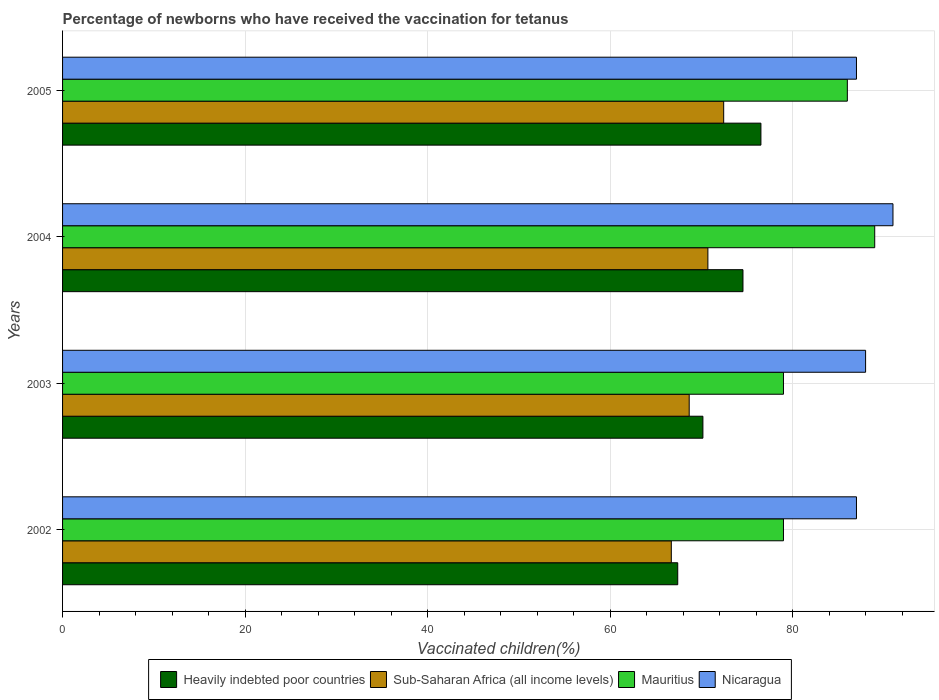How many groups of bars are there?
Ensure brevity in your answer.  4. Are the number of bars on each tick of the Y-axis equal?
Give a very brief answer. Yes. How many bars are there on the 2nd tick from the top?
Give a very brief answer. 4. How many bars are there on the 2nd tick from the bottom?
Provide a short and direct response. 4. What is the label of the 1st group of bars from the top?
Provide a short and direct response. 2005. In how many cases, is the number of bars for a given year not equal to the number of legend labels?
Make the answer very short. 0. What is the percentage of vaccinated children in Sub-Saharan Africa (all income levels) in 2002?
Ensure brevity in your answer.  66.71. Across all years, what is the maximum percentage of vaccinated children in Nicaragua?
Offer a terse response. 91. Across all years, what is the minimum percentage of vaccinated children in Sub-Saharan Africa (all income levels)?
Keep it short and to the point. 66.71. What is the total percentage of vaccinated children in Heavily indebted poor countries in the graph?
Give a very brief answer. 288.68. What is the difference between the percentage of vaccinated children in Heavily indebted poor countries in 2003 and that in 2005?
Provide a short and direct response. -6.36. What is the difference between the percentage of vaccinated children in Heavily indebted poor countries in 2004 and the percentage of vaccinated children in Sub-Saharan Africa (all income levels) in 2002?
Provide a short and direct response. 7.85. What is the average percentage of vaccinated children in Mauritius per year?
Offer a terse response. 83.25. In the year 2004, what is the difference between the percentage of vaccinated children in Heavily indebted poor countries and percentage of vaccinated children in Sub-Saharan Africa (all income levels)?
Your answer should be very brief. 3.85. What is the ratio of the percentage of vaccinated children in Nicaragua in 2003 to that in 2005?
Make the answer very short. 1.01. Is the percentage of vaccinated children in Heavily indebted poor countries in 2003 less than that in 2005?
Offer a terse response. Yes. What is the difference between the highest and the second highest percentage of vaccinated children in Heavily indebted poor countries?
Provide a short and direct response. 1.97. What is the difference between the highest and the lowest percentage of vaccinated children in Heavily indebted poor countries?
Ensure brevity in your answer.  9.12. Is the sum of the percentage of vaccinated children in Sub-Saharan Africa (all income levels) in 2003 and 2005 greater than the maximum percentage of vaccinated children in Nicaragua across all years?
Your answer should be compact. Yes. What does the 1st bar from the top in 2002 represents?
Make the answer very short. Nicaragua. What does the 2nd bar from the bottom in 2003 represents?
Your answer should be compact. Sub-Saharan Africa (all income levels). Are all the bars in the graph horizontal?
Give a very brief answer. Yes. What is the difference between two consecutive major ticks on the X-axis?
Offer a terse response. 20. Does the graph contain any zero values?
Offer a very short reply. No. How many legend labels are there?
Your answer should be compact. 4. How are the legend labels stacked?
Your answer should be very brief. Horizontal. What is the title of the graph?
Provide a short and direct response. Percentage of newborns who have received the vaccination for tetanus. What is the label or title of the X-axis?
Make the answer very short. Vaccinated children(%). What is the label or title of the Y-axis?
Your response must be concise. Years. What is the Vaccinated children(%) of Heavily indebted poor countries in 2002?
Ensure brevity in your answer.  67.41. What is the Vaccinated children(%) of Sub-Saharan Africa (all income levels) in 2002?
Provide a succinct answer. 66.71. What is the Vaccinated children(%) in Mauritius in 2002?
Make the answer very short. 79. What is the Vaccinated children(%) of Heavily indebted poor countries in 2003?
Your answer should be very brief. 70.17. What is the Vaccinated children(%) of Sub-Saharan Africa (all income levels) in 2003?
Give a very brief answer. 68.67. What is the Vaccinated children(%) in Mauritius in 2003?
Your answer should be compact. 79. What is the Vaccinated children(%) of Nicaragua in 2003?
Give a very brief answer. 88. What is the Vaccinated children(%) in Heavily indebted poor countries in 2004?
Your response must be concise. 74.56. What is the Vaccinated children(%) in Sub-Saharan Africa (all income levels) in 2004?
Your answer should be compact. 70.72. What is the Vaccinated children(%) in Mauritius in 2004?
Your response must be concise. 89. What is the Vaccinated children(%) in Nicaragua in 2004?
Your answer should be compact. 91. What is the Vaccinated children(%) of Heavily indebted poor countries in 2005?
Offer a very short reply. 76.53. What is the Vaccinated children(%) of Sub-Saharan Africa (all income levels) in 2005?
Offer a terse response. 72.45. What is the Vaccinated children(%) of Mauritius in 2005?
Give a very brief answer. 86. What is the Vaccinated children(%) of Nicaragua in 2005?
Provide a succinct answer. 87. Across all years, what is the maximum Vaccinated children(%) in Heavily indebted poor countries?
Your answer should be very brief. 76.53. Across all years, what is the maximum Vaccinated children(%) in Sub-Saharan Africa (all income levels)?
Provide a short and direct response. 72.45. Across all years, what is the maximum Vaccinated children(%) in Mauritius?
Your response must be concise. 89. Across all years, what is the maximum Vaccinated children(%) in Nicaragua?
Your answer should be very brief. 91. Across all years, what is the minimum Vaccinated children(%) in Heavily indebted poor countries?
Provide a short and direct response. 67.41. Across all years, what is the minimum Vaccinated children(%) of Sub-Saharan Africa (all income levels)?
Offer a terse response. 66.71. Across all years, what is the minimum Vaccinated children(%) of Mauritius?
Ensure brevity in your answer.  79. Across all years, what is the minimum Vaccinated children(%) in Nicaragua?
Offer a very short reply. 87. What is the total Vaccinated children(%) in Heavily indebted poor countries in the graph?
Provide a short and direct response. 288.68. What is the total Vaccinated children(%) of Sub-Saharan Africa (all income levels) in the graph?
Your response must be concise. 278.55. What is the total Vaccinated children(%) in Mauritius in the graph?
Provide a succinct answer. 333. What is the total Vaccinated children(%) of Nicaragua in the graph?
Give a very brief answer. 353. What is the difference between the Vaccinated children(%) of Heavily indebted poor countries in 2002 and that in 2003?
Provide a succinct answer. -2.76. What is the difference between the Vaccinated children(%) of Sub-Saharan Africa (all income levels) in 2002 and that in 2003?
Ensure brevity in your answer.  -1.96. What is the difference between the Vaccinated children(%) in Mauritius in 2002 and that in 2003?
Your answer should be very brief. 0. What is the difference between the Vaccinated children(%) in Heavily indebted poor countries in 2002 and that in 2004?
Provide a succinct answer. -7.15. What is the difference between the Vaccinated children(%) in Sub-Saharan Africa (all income levels) in 2002 and that in 2004?
Your answer should be very brief. -4.01. What is the difference between the Vaccinated children(%) in Nicaragua in 2002 and that in 2004?
Offer a terse response. -4. What is the difference between the Vaccinated children(%) in Heavily indebted poor countries in 2002 and that in 2005?
Make the answer very short. -9.12. What is the difference between the Vaccinated children(%) of Sub-Saharan Africa (all income levels) in 2002 and that in 2005?
Your answer should be compact. -5.74. What is the difference between the Vaccinated children(%) in Heavily indebted poor countries in 2003 and that in 2004?
Give a very brief answer. -4.39. What is the difference between the Vaccinated children(%) in Sub-Saharan Africa (all income levels) in 2003 and that in 2004?
Give a very brief answer. -2.05. What is the difference between the Vaccinated children(%) in Heavily indebted poor countries in 2003 and that in 2005?
Make the answer very short. -6.36. What is the difference between the Vaccinated children(%) in Sub-Saharan Africa (all income levels) in 2003 and that in 2005?
Give a very brief answer. -3.78. What is the difference between the Vaccinated children(%) in Mauritius in 2003 and that in 2005?
Make the answer very short. -7. What is the difference between the Vaccinated children(%) in Heavily indebted poor countries in 2004 and that in 2005?
Make the answer very short. -1.97. What is the difference between the Vaccinated children(%) of Sub-Saharan Africa (all income levels) in 2004 and that in 2005?
Give a very brief answer. -1.73. What is the difference between the Vaccinated children(%) in Heavily indebted poor countries in 2002 and the Vaccinated children(%) in Sub-Saharan Africa (all income levels) in 2003?
Give a very brief answer. -1.26. What is the difference between the Vaccinated children(%) in Heavily indebted poor countries in 2002 and the Vaccinated children(%) in Mauritius in 2003?
Ensure brevity in your answer.  -11.59. What is the difference between the Vaccinated children(%) of Heavily indebted poor countries in 2002 and the Vaccinated children(%) of Nicaragua in 2003?
Offer a terse response. -20.59. What is the difference between the Vaccinated children(%) of Sub-Saharan Africa (all income levels) in 2002 and the Vaccinated children(%) of Mauritius in 2003?
Your answer should be compact. -12.29. What is the difference between the Vaccinated children(%) in Sub-Saharan Africa (all income levels) in 2002 and the Vaccinated children(%) in Nicaragua in 2003?
Provide a succinct answer. -21.29. What is the difference between the Vaccinated children(%) in Heavily indebted poor countries in 2002 and the Vaccinated children(%) in Sub-Saharan Africa (all income levels) in 2004?
Make the answer very short. -3.3. What is the difference between the Vaccinated children(%) of Heavily indebted poor countries in 2002 and the Vaccinated children(%) of Mauritius in 2004?
Keep it short and to the point. -21.59. What is the difference between the Vaccinated children(%) in Heavily indebted poor countries in 2002 and the Vaccinated children(%) in Nicaragua in 2004?
Make the answer very short. -23.59. What is the difference between the Vaccinated children(%) of Sub-Saharan Africa (all income levels) in 2002 and the Vaccinated children(%) of Mauritius in 2004?
Give a very brief answer. -22.29. What is the difference between the Vaccinated children(%) in Sub-Saharan Africa (all income levels) in 2002 and the Vaccinated children(%) in Nicaragua in 2004?
Make the answer very short. -24.29. What is the difference between the Vaccinated children(%) in Heavily indebted poor countries in 2002 and the Vaccinated children(%) in Sub-Saharan Africa (all income levels) in 2005?
Keep it short and to the point. -5.04. What is the difference between the Vaccinated children(%) of Heavily indebted poor countries in 2002 and the Vaccinated children(%) of Mauritius in 2005?
Provide a succinct answer. -18.59. What is the difference between the Vaccinated children(%) in Heavily indebted poor countries in 2002 and the Vaccinated children(%) in Nicaragua in 2005?
Keep it short and to the point. -19.59. What is the difference between the Vaccinated children(%) of Sub-Saharan Africa (all income levels) in 2002 and the Vaccinated children(%) of Mauritius in 2005?
Offer a very short reply. -19.29. What is the difference between the Vaccinated children(%) in Sub-Saharan Africa (all income levels) in 2002 and the Vaccinated children(%) in Nicaragua in 2005?
Provide a succinct answer. -20.29. What is the difference between the Vaccinated children(%) in Heavily indebted poor countries in 2003 and the Vaccinated children(%) in Sub-Saharan Africa (all income levels) in 2004?
Provide a succinct answer. -0.54. What is the difference between the Vaccinated children(%) in Heavily indebted poor countries in 2003 and the Vaccinated children(%) in Mauritius in 2004?
Your answer should be very brief. -18.83. What is the difference between the Vaccinated children(%) of Heavily indebted poor countries in 2003 and the Vaccinated children(%) of Nicaragua in 2004?
Give a very brief answer. -20.83. What is the difference between the Vaccinated children(%) of Sub-Saharan Africa (all income levels) in 2003 and the Vaccinated children(%) of Mauritius in 2004?
Your answer should be very brief. -20.33. What is the difference between the Vaccinated children(%) of Sub-Saharan Africa (all income levels) in 2003 and the Vaccinated children(%) of Nicaragua in 2004?
Provide a succinct answer. -22.33. What is the difference between the Vaccinated children(%) in Mauritius in 2003 and the Vaccinated children(%) in Nicaragua in 2004?
Offer a very short reply. -12. What is the difference between the Vaccinated children(%) of Heavily indebted poor countries in 2003 and the Vaccinated children(%) of Sub-Saharan Africa (all income levels) in 2005?
Ensure brevity in your answer.  -2.28. What is the difference between the Vaccinated children(%) in Heavily indebted poor countries in 2003 and the Vaccinated children(%) in Mauritius in 2005?
Provide a succinct answer. -15.83. What is the difference between the Vaccinated children(%) of Heavily indebted poor countries in 2003 and the Vaccinated children(%) of Nicaragua in 2005?
Ensure brevity in your answer.  -16.83. What is the difference between the Vaccinated children(%) of Sub-Saharan Africa (all income levels) in 2003 and the Vaccinated children(%) of Mauritius in 2005?
Ensure brevity in your answer.  -17.33. What is the difference between the Vaccinated children(%) of Sub-Saharan Africa (all income levels) in 2003 and the Vaccinated children(%) of Nicaragua in 2005?
Your answer should be very brief. -18.33. What is the difference between the Vaccinated children(%) in Heavily indebted poor countries in 2004 and the Vaccinated children(%) in Sub-Saharan Africa (all income levels) in 2005?
Offer a very short reply. 2.11. What is the difference between the Vaccinated children(%) of Heavily indebted poor countries in 2004 and the Vaccinated children(%) of Mauritius in 2005?
Ensure brevity in your answer.  -11.44. What is the difference between the Vaccinated children(%) in Heavily indebted poor countries in 2004 and the Vaccinated children(%) in Nicaragua in 2005?
Provide a succinct answer. -12.44. What is the difference between the Vaccinated children(%) in Sub-Saharan Africa (all income levels) in 2004 and the Vaccinated children(%) in Mauritius in 2005?
Provide a succinct answer. -15.28. What is the difference between the Vaccinated children(%) in Sub-Saharan Africa (all income levels) in 2004 and the Vaccinated children(%) in Nicaragua in 2005?
Provide a succinct answer. -16.28. What is the average Vaccinated children(%) of Heavily indebted poor countries per year?
Give a very brief answer. 72.17. What is the average Vaccinated children(%) of Sub-Saharan Africa (all income levels) per year?
Your response must be concise. 69.64. What is the average Vaccinated children(%) of Mauritius per year?
Ensure brevity in your answer.  83.25. What is the average Vaccinated children(%) of Nicaragua per year?
Give a very brief answer. 88.25. In the year 2002, what is the difference between the Vaccinated children(%) of Heavily indebted poor countries and Vaccinated children(%) of Sub-Saharan Africa (all income levels)?
Offer a very short reply. 0.7. In the year 2002, what is the difference between the Vaccinated children(%) of Heavily indebted poor countries and Vaccinated children(%) of Mauritius?
Provide a succinct answer. -11.59. In the year 2002, what is the difference between the Vaccinated children(%) of Heavily indebted poor countries and Vaccinated children(%) of Nicaragua?
Provide a succinct answer. -19.59. In the year 2002, what is the difference between the Vaccinated children(%) in Sub-Saharan Africa (all income levels) and Vaccinated children(%) in Mauritius?
Provide a succinct answer. -12.29. In the year 2002, what is the difference between the Vaccinated children(%) in Sub-Saharan Africa (all income levels) and Vaccinated children(%) in Nicaragua?
Your answer should be very brief. -20.29. In the year 2002, what is the difference between the Vaccinated children(%) of Mauritius and Vaccinated children(%) of Nicaragua?
Provide a succinct answer. -8. In the year 2003, what is the difference between the Vaccinated children(%) of Heavily indebted poor countries and Vaccinated children(%) of Sub-Saharan Africa (all income levels)?
Ensure brevity in your answer.  1.5. In the year 2003, what is the difference between the Vaccinated children(%) in Heavily indebted poor countries and Vaccinated children(%) in Mauritius?
Offer a terse response. -8.83. In the year 2003, what is the difference between the Vaccinated children(%) in Heavily indebted poor countries and Vaccinated children(%) in Nicaragua?
Give a very brief answer. -17.83. In the year 2003, what is the difference between the Vaccinated children(%) of Sub-Saharan Africa (all income levels) and Vaccinated children(%) of Mauritius?
Your response must be concise. -10.33. In the year 2003, what is the difference between the Vaccinated children(%) of Sub-Saharan Africa (all income levels) and Vaccinated children(%) of Nicaragua?
Ensure brevity in your answer.  -19.33. In the year 2004, what is the difference between the Vaccinated children(%) of Heavily indebted poor countries and Vaccinated children(%) of Sub-Saharan Africa (all income levels)?
Provide a succinct answer. 3.85. In the year 2004, what is the difference between the Vaccinated children(%) in Heavily indebted poor countries and Vaccinated children(%) in Mauritius?
Make the answer very short. -14.44. In the year 2004, what is the difference between the Vaccinated children(%) in Heavily indebted poor countries and Vaccinated children(%) in Nicaragua?
Your response must be concise. -16.44. In the year 2004, what is the difference between the Vaccinated children(%) in Sub-Saharan Africa (all income levels) and Vaccinated children(%) in Mauritius?
Provide a succinct answer. -18.28. In the year 2004, what is the difference between the Vaccinated children(%) in Sub-Saharan Africa (all income levels) and Vaccinated children(%) in Nicaragua?
Provide a short and direct response. -20.28. In the year 2005, what is the difference between the Vaccinated children(%) of Heavily indebted poor countries and Vaccinated children(%) of Sub-Saharan Africa (all income levels)?
Provide a succinct answer. 4.08. In the year 2005, what is the difference between the Vaccinated children(%) of Heavily indebted poor countries and Vaccinated children(%) of Mauritius?
Your answer should be very brief. -9.47. In the year 2005, what is the difference between the Vaccinated children(%) in Heavily indebted poor countries and Vaccinated children(%) in Nicaragua?
Provide a succinct answer. -10.47. In the year 2005, what is the difference between the Vaccinated children(%) of Sub-Saharan Africa (all income levels) and Vaccinated children(%) of Mauritius?
Ensure brevity in your answer.  -13.55. In the year 2005, what is the difference between the Vaccinated children(%) in Sub-Saharan Africa (all income levels) and Vaccinated children(%) in Nicaragua?
Offer a terse response. -14.55. In the year 2005, what is the difference between the Vaccinated children(%) of Mauritius and Vaccinated children(%) of Nicaragua?
Make the answer very short. -1. What is the ratio of the Vaccinated children(%) in Heavily indebted poor countries in 2002 to that in 2003?
Keep it short and to the point. 0.96. What is the ratio of the Vaccinated children(%) in Sub-Saharan Africa (all income levels) in 2002 to that in 2003?
Ensure brevity in your answer.  0.97. What is the ratio of the Vaccinated children(%) in Mauritius in 2002 to that in 2003?
Offer a very short reply. 1. What is the ratio of the Vaccinated children(%) in Nicaragua in 2002 to that in 2003?
Offer a very short reply. 0.99. What is the ratio of the Vaccinated children(%) of Heavily indebted poor countries in 2002 to that in 2004?
Provide a succinct answer. 0.9. What is the ratio of the Vaccinated children(%) of Sub-Saharan Africa (all income levels) in 2002 to that in 2004?
Offer a terse response. 0.94. What is the ratio of the Vaccinated children(%) of Mauritius in 2002 to that in 2004?
Keep it short and to the point. 0.89. What is the ratio of the Vaccinated children(%) of Nicaragua in 2002 to that in 2004?
Offer a very short reply. 0.96. What is the ratio of the Vaccinated children(%) in Heavily indebted poor countries in 2002 to that in 2005?
Provide a short and direct response. 0.88. What is the ratio of the Vaccinated children(%) in Sub-Saharan Africa (all income levels) in 2002 to that in 2005?
Provide a short and direct response. 0.92. What is the ratio of the Vaccinated children(%) in Mauritius in 2002 to that in 2005?
Make the answer very short. 0.92. What is the ratio of the Vaccinated children(%) of Nicaragua in 2002 to that in 2005?
Offer a terse response. 1. What is the ratio of the Vaccinated children(%) in Heavily indebted poor countries in 2003 to that in 2004?
Keep it short and to the point. 0.94. What is the ratio of the Vaccinated children(%) of Sub-Saharan Africa (all income levels) in 2003 to that in 2004?
Offer a very short reply. 0.97. What is the ratio of the Vaccinated children(%) in Mauritius in 2003 to that in 2004?
Make the answer very short. 0.89. What is the ratio of the Vaccinated children(%) in Heavily indebted poor countries in 2003 to that in 2005?
Provide a short and direct response. 0.92. What is the ratio of the Vaccinated children(%) of Sub-Saharan Africa (all income levels) in 2003 to that in 2005?
Your answer should be compact. 0.95. What is the ratio of the Vaccinated children(%) in Mauritius in 2003 to that in 2005?
Your response must be concise. 0.92. What is the ratio of the Vaccinated children(%) in Nicaragua in 2003 to that in 2005?
Provide a succinct answer. 1.01. What is the ratio of the Vaccinated children(%) in Heavily indebted poor countries in 2004 to that in 2005?
Ensure brevity in your answer.  0.97. What is the ratio of the Vaccinated children(%) of Sub-Saharan Africa (all income levels) in 2004 to that in 2005?
Provide a short and direct response. 0.98. What is the ratio of the Vaccinated children(%) in Mauritius in 2004 to that in 2005?
Ensure brevity in your answer.  1.03. What is the ratio of the Vaccinated children(%) in Nicaragua in 2004 to that in 2005?
Provide a short and direct response. 1.05. What is the difference between the highest and the second highest Vaccinated children(%) of Heavily indebted poor countries?
Make the answer very short. 1.97. What is the difference between the highest and the second highest Vaccinated children(%) of Sub-Saharan Africa (all income levels)?
Ensure brevity in your answer.  1.73. What is the difference between the highest and the second highest Vaccinated children(%) in Nicaragua?
Offer a very short reply. 3. What is the difference between the highest and the lowest Vaccinated children(%) of Heavily indebted poor countries?
Provide a short and direct response. 9.12. What is the difference between the highest and the lowest Vaccinated children(%) in Sub-Saharan Africa (all income levels)?
Ensure brevity in your answer.  5.74. What is the difference between the highest and the lowest Vaccinated children(%) of Mauritius?
Offer a terse response. 10. 